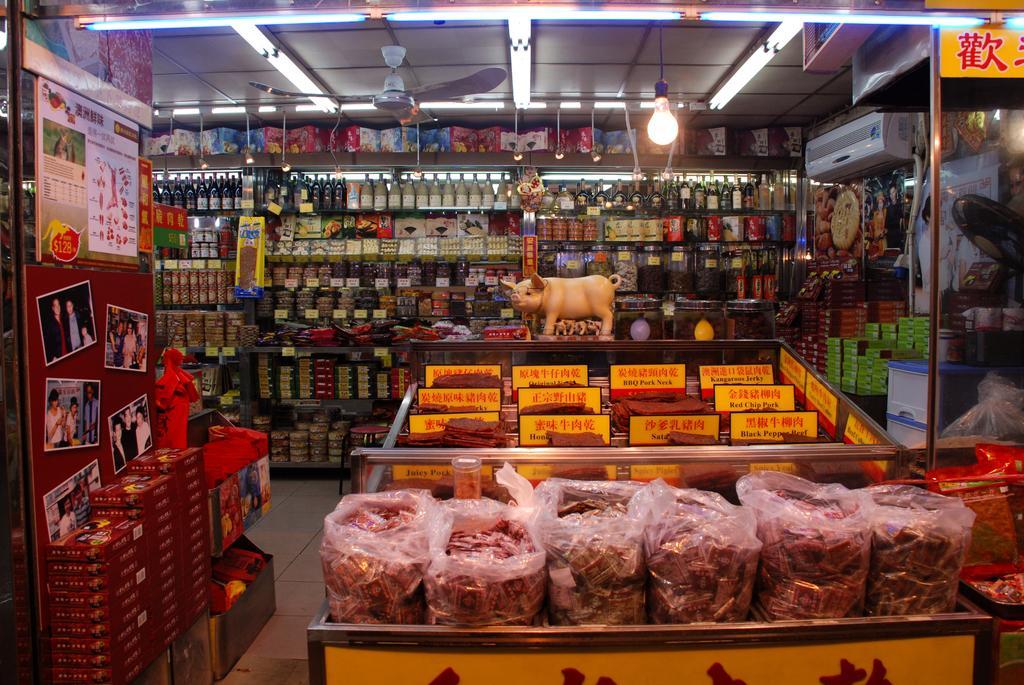How would you summarize this image in a sentence or two? In the center of the image there is a fan, board with a collection of photos, lights, bottles, boxes, plastic covers with some objects in it, boards with some text, different types of products and a few other objects. 